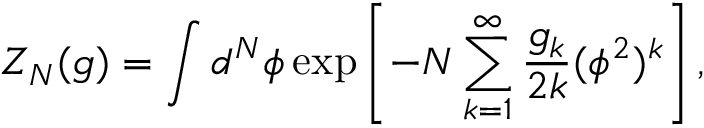<formula> <loc_0><loc_0><loc_500><loc_500>Z _ { N } ( g ) = \int d ^ { N } \phi \exp \left [ - N \sum _ { k = 1 } ^ { \infty } \frac { g _ { k } } { 2 k } ( \phi ^ { 2 } ) ^ { k } \right ] ,</formula> 